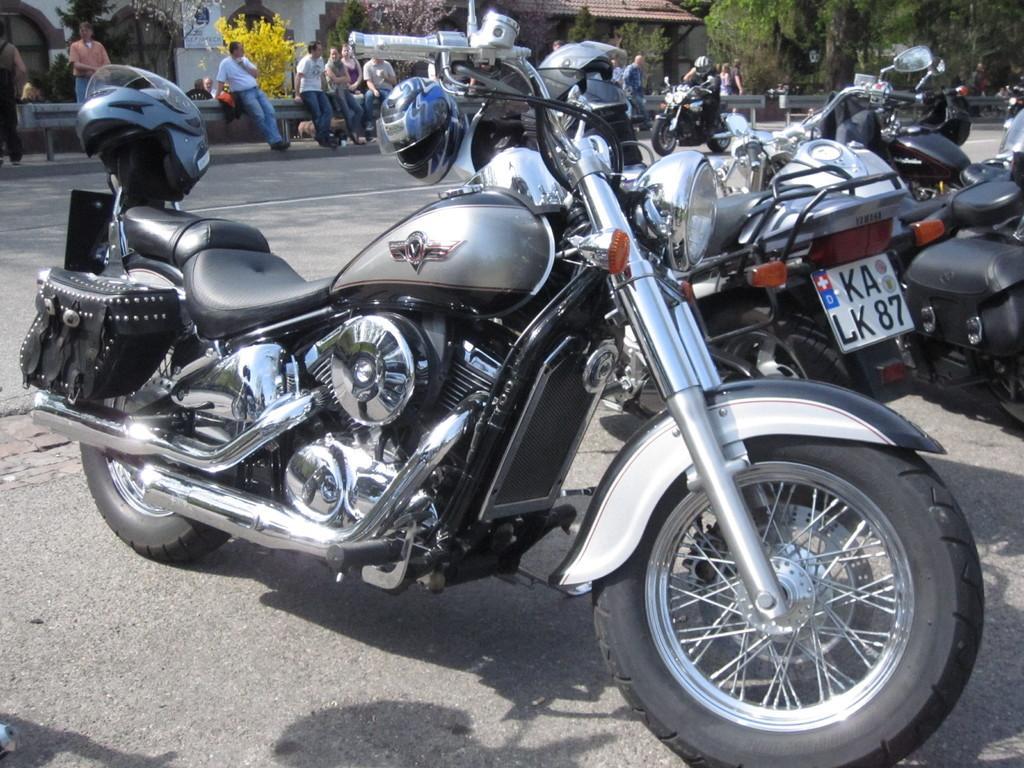Can you describe this image briefly? In the center of the image there are vehicles on the road. In the background of the image there are people,building,trees. 